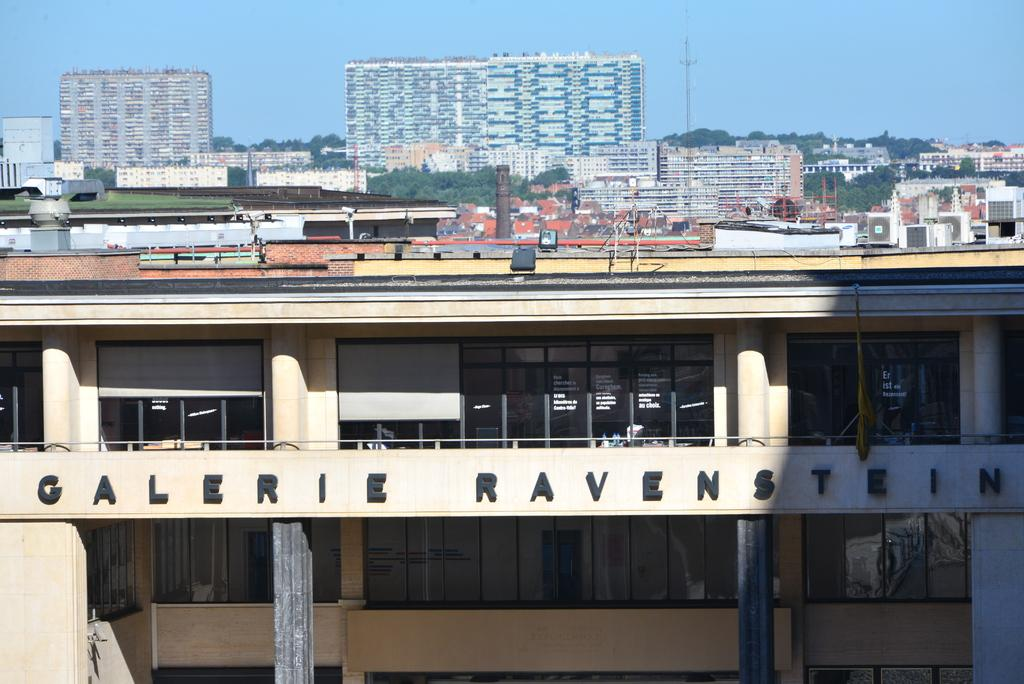What type of structures are present in the image? There are buildings in the image. Can you describe any specific features on the buildings? Yes, there is 3D text on one of the buildings. What is visible at the top of the image? The sky is visible at the top of the image. What type of silver object can be seen in the image? There is no silver object present in the image. Can you read the receipt on the building in the image? There is no receipt present in the image; it features 3D text on one of the buildings. 